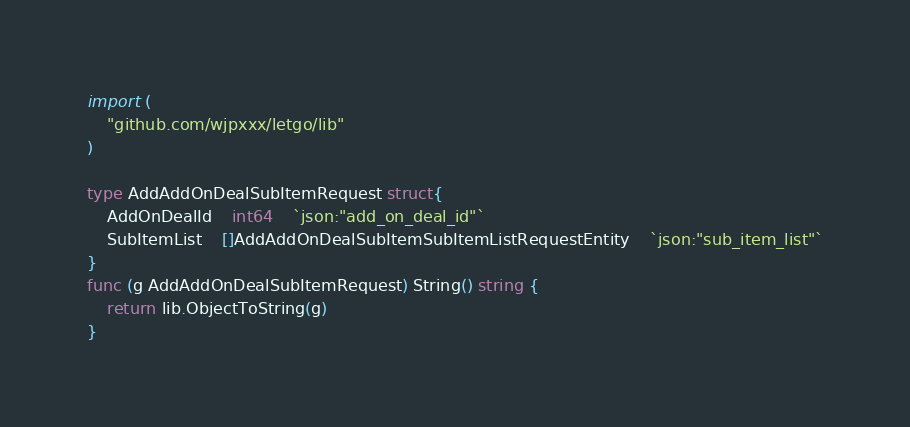<code> <loc_0><loc_0><loc_500><loc_500><_Go_>
import (
    "github.com/wjpxxx/letgo/lib"
)

type AddAddOnDealSubItemRequest struct{
    AddOnDealId	int64	`json:"add_on_deal_id"`
    SubItemList	[]AddAddOnDealSubItemSubItemListRequestEntity	`json:"sub_item_list"`
}
func (g AddAddOnDealSubItemRequest) String() string {
    return lib.ObjectToString(g)
}
</code> 